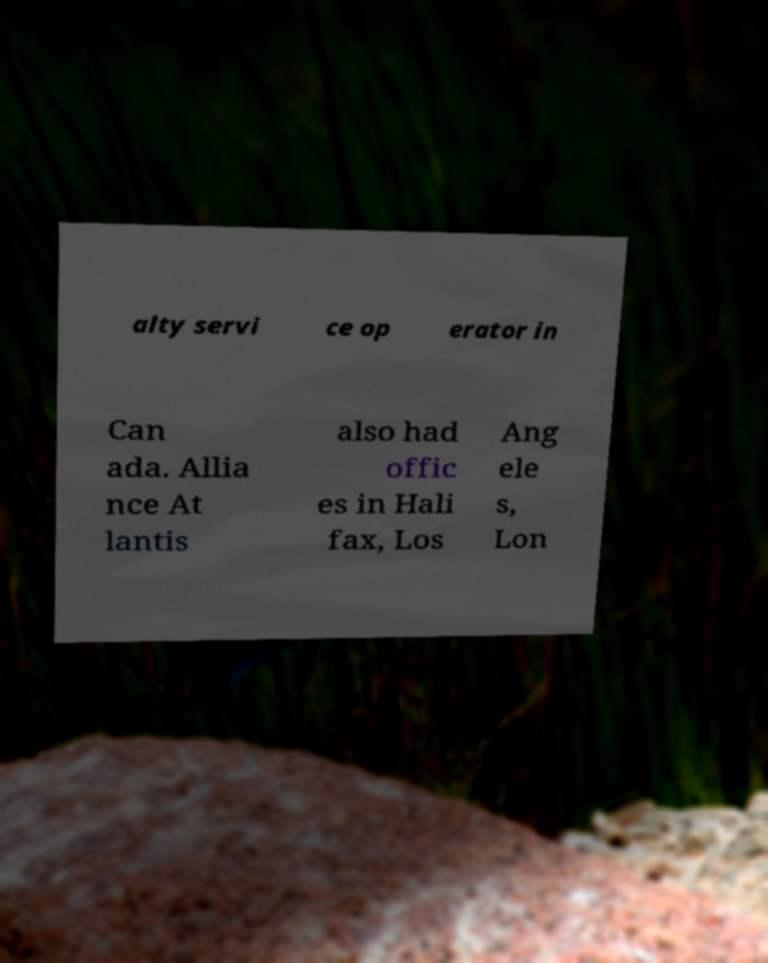Please read and relay the text visible in this image. What does it say? alty servi ce op erator in Can ada. Allia nce At lantis also had offic es in Hali fax, Los Ang ele s, Lon 